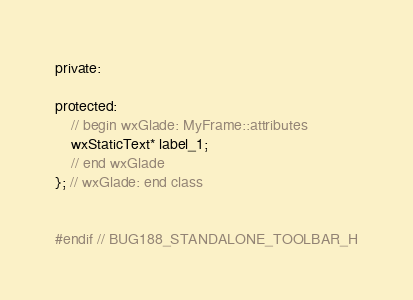<code> <loc_0><loc_0><loc_500><loc_500><_C_>
private:

protected:
    // begin wxGlade: MyFrame::attributes
    wxStaticText* label_1;
    // end wxGlade
}; // wxGlade: end class


#endif // BUG188_STANDALONE_TOOLBAR_H
</code> 